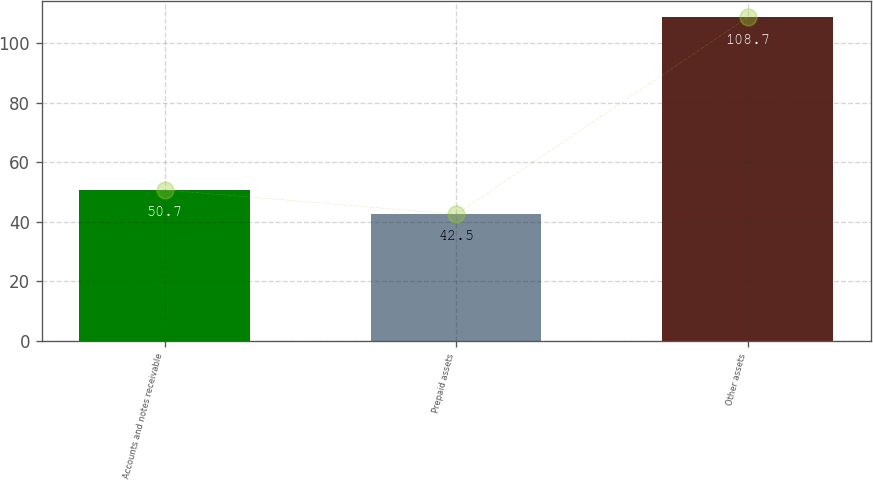<chart> <loc_0><loc_0><loc_500><loc_500><bar_chart><fcel>Accounts and notes receivable<fcel>Prepaid assets<fcel>Other assets<nl><fcel>50.7<fcel>42.5<fcel>108.7<nl></chart> 